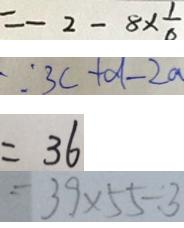Convert formula to latex. <formula><loc_0><loc_0><loc_500><loc_500>= - 2 - 8 \times \frac { 1 } { 6 } 
 \because 3 c + d - 2 a 
 = 3 6 
 = 3 9 \times 5 5 \div 3</formula> 